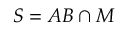Convert formula to latex. <formula><loc_0><loc_0><loc_500><loc_500>S = A B \cap M</formula> 